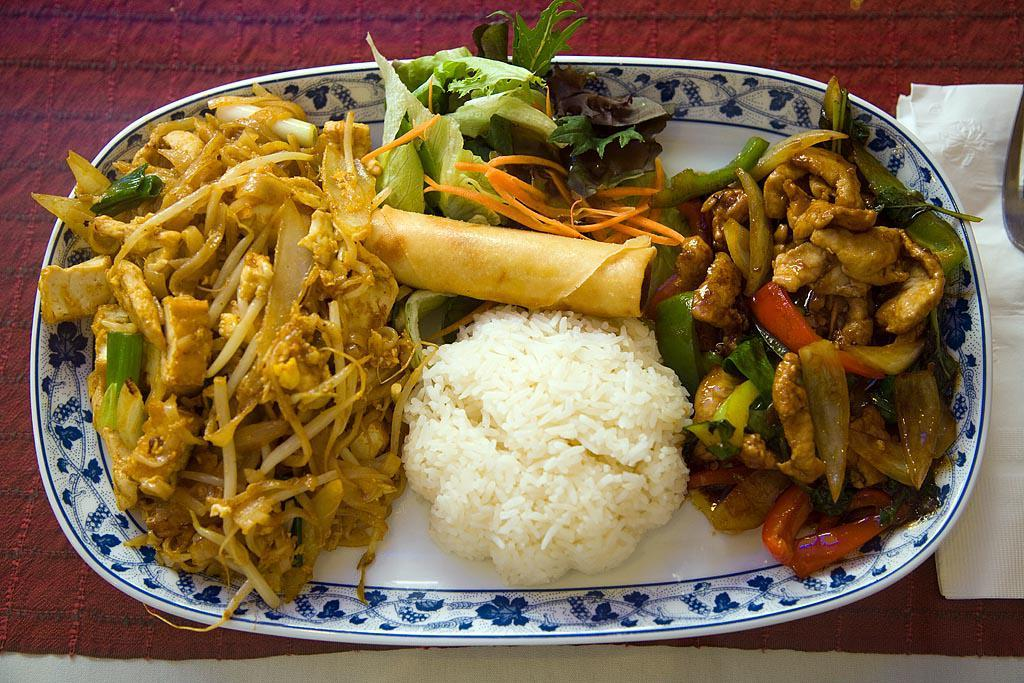What type of food can be seen in the image? There is rice and a roll in the image, along with other food items. How are the food items arranged in the image? The food items are on a plate in the image. Where is the plate located in the image? The plate is on a table in the image. What else can be seen on the table in the image? There is tissue paper and a spoon on the table in the image. What type of scarecrow is present in the image? There is no scarecrow present in the image; it features food items on a plate. How many loaves of bread are visible in the image? There is no loaf of bread present in the image; it features rice, a roll, and other food items. 